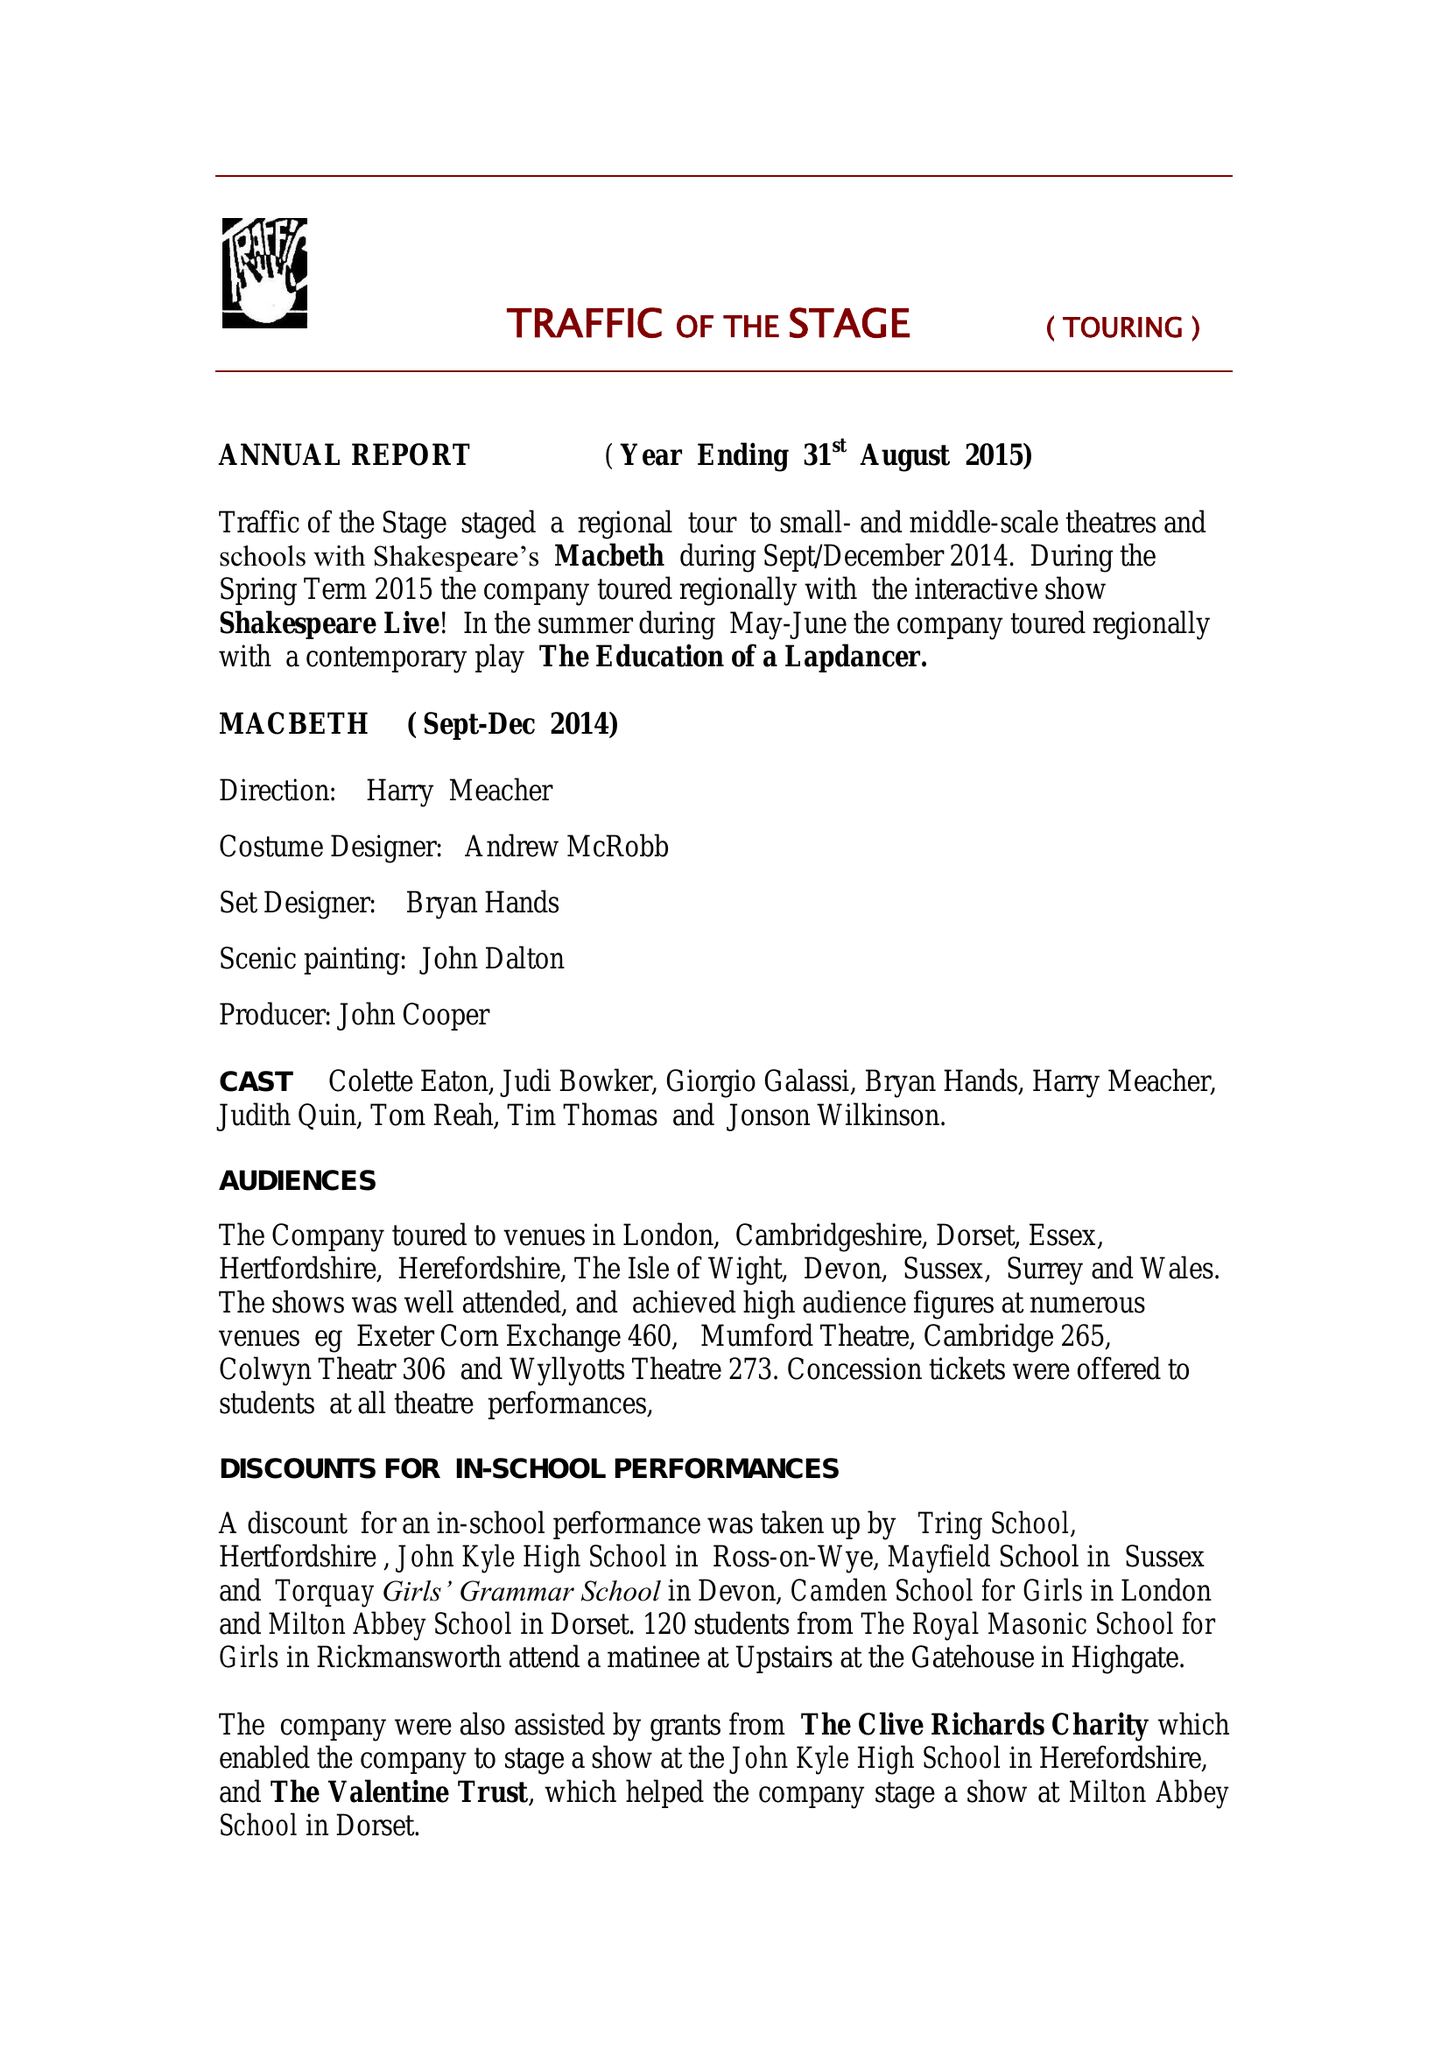What is the value for the address__street_line?
Answer the question using a single word or phrase. TORRINGTON 